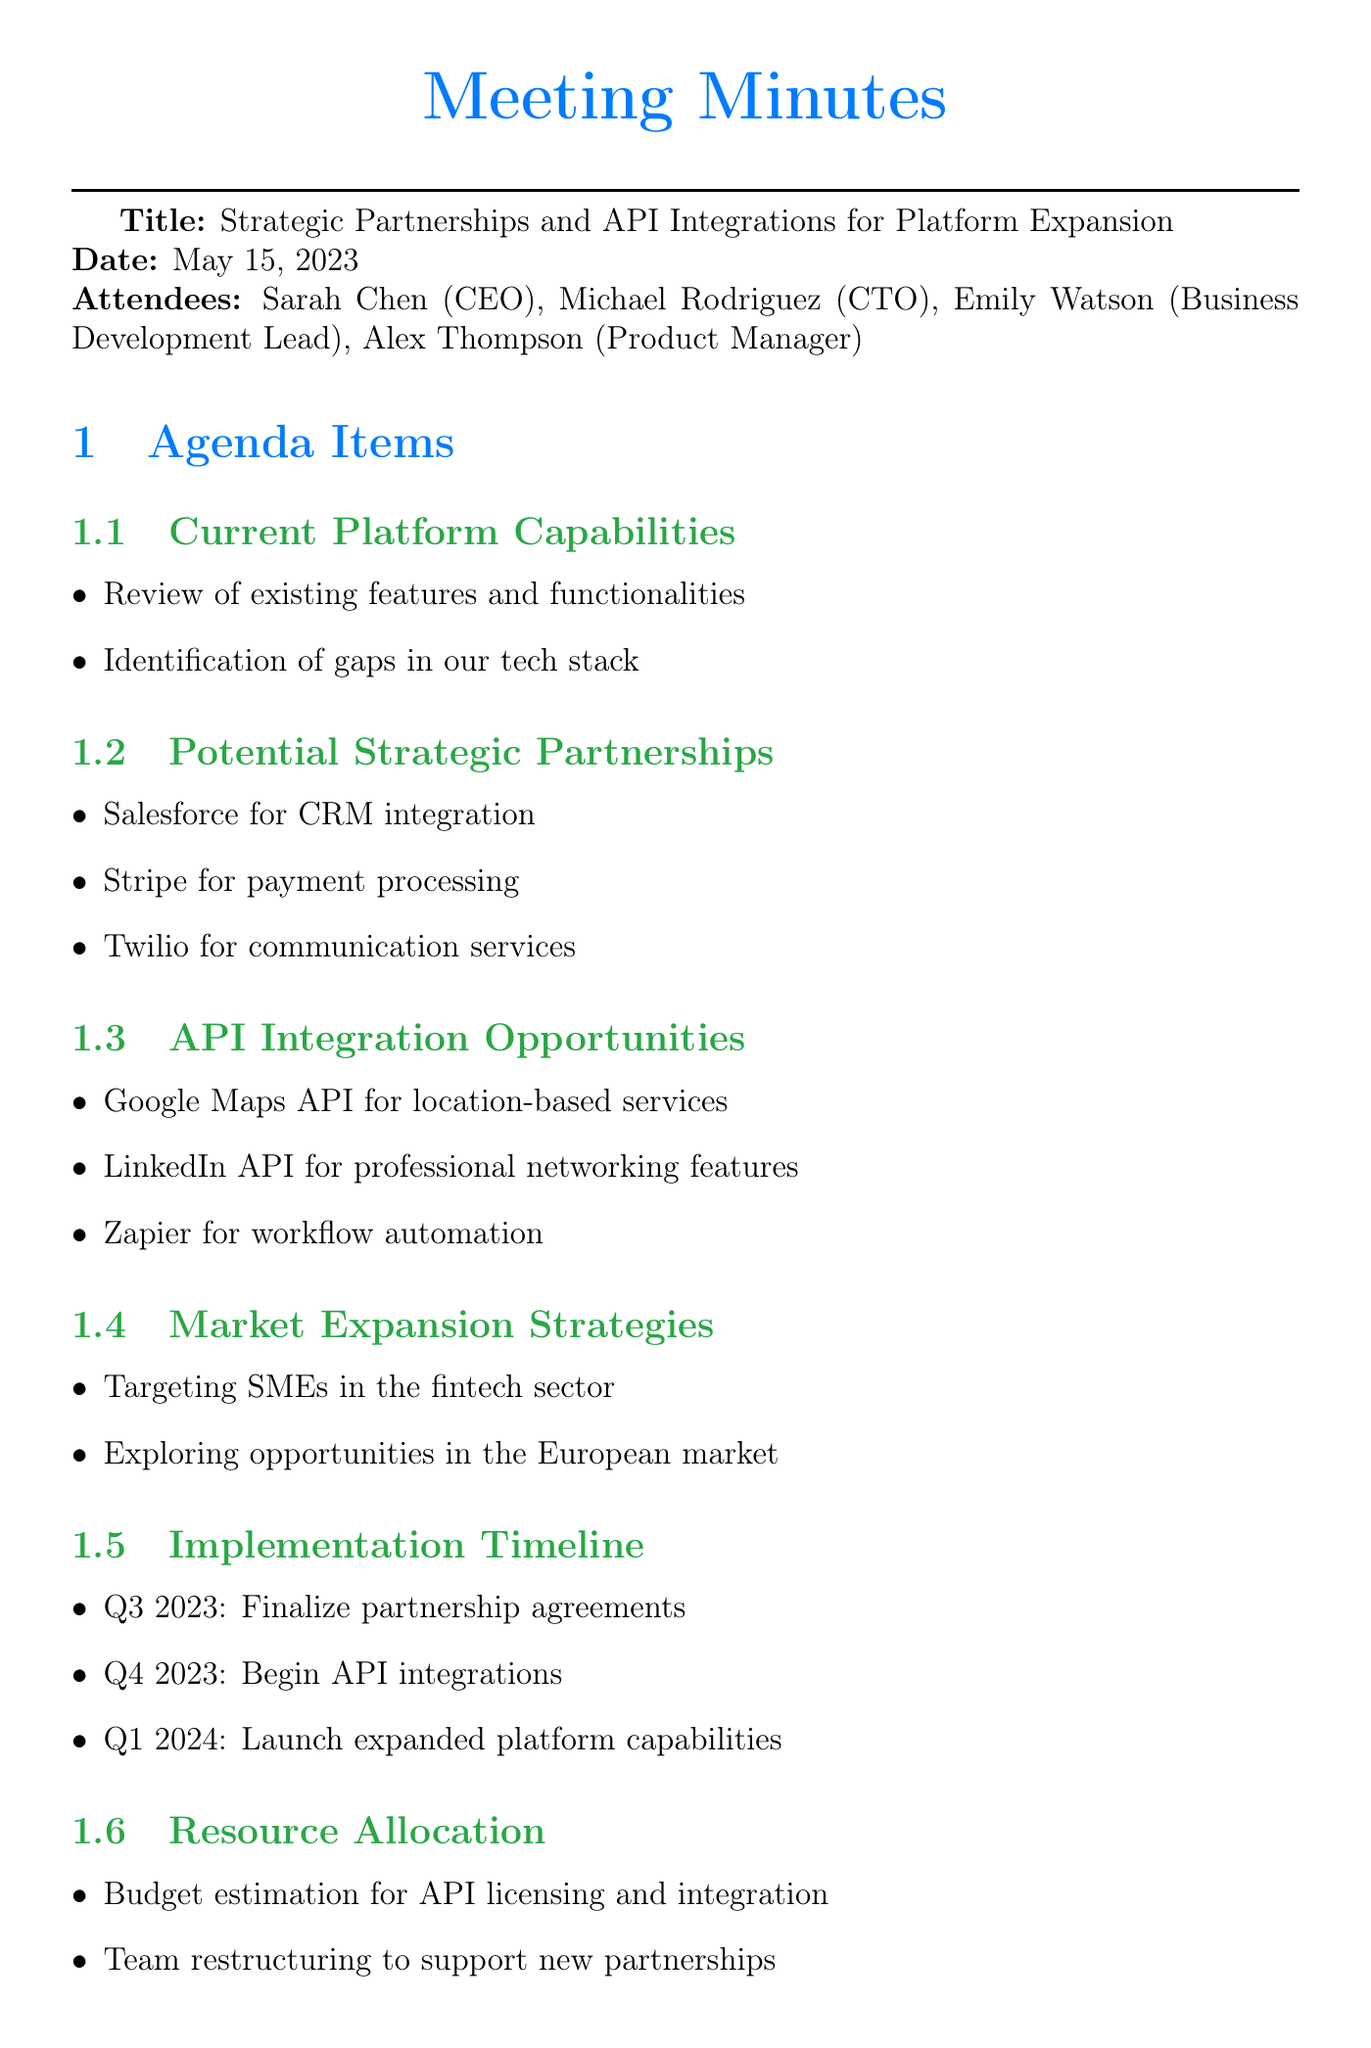What is the meeting title? The meeting title is stated at the beginning of the document as "Strategic Partnerships and API Integrations for Platform Expansion."
Answer: Strategic Partnerships and API Integrations for Platform Expansion Who attended the meeting? The list of attendees is provided in the "Attendees" section, including their roles.
Answer: Sarah Chen, Michael Rodriguez, Emily Watson, Alex Thompson What are the potential strategic partnerships mentioned? The "Potential Strategic Partnerships" section contains specific companies listed for potential collaboration.
Answer: Salesforce, Stripe, Twilio What is the timeline for finalizing partnership agreements? The "Implementation Timeline" specifies the timeline for each key milestone, including finalizing partnerships.
Answer: Q3 2023 Which API is suggested for workflow automation? Under "API Integration Opportunities," an API is specifically suggested for automating workflows.
Answer: Zapier What is the main market expansion strategy? The "Market Expansion Strategies" section outlines the target market for expansion and provides specifics.
Answer: Targeting SMEs in the fintech sector Who is responsible for evaluating technical requirements for API integrations? In the "Action Items" section, responsibilities are assigned to specific attendees for various tasks.
Answer: Michael What budget aspect is addressed in the document? The "Resource Allocation" section discusses budget considerations associated with new projects.
Answer: Budget estimation for API licensing and integration 